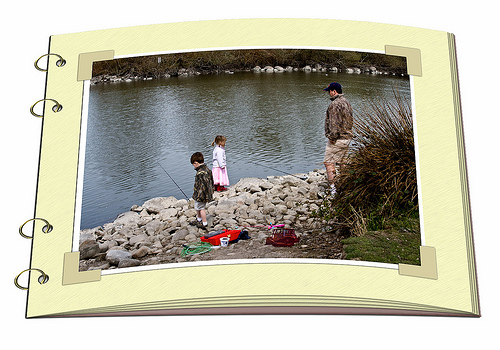<image>
Is the girl behind the boy? No. The girl is not behind the boy. From this viewpoint, the girl appears to be positioned elsewhere in the scene. 